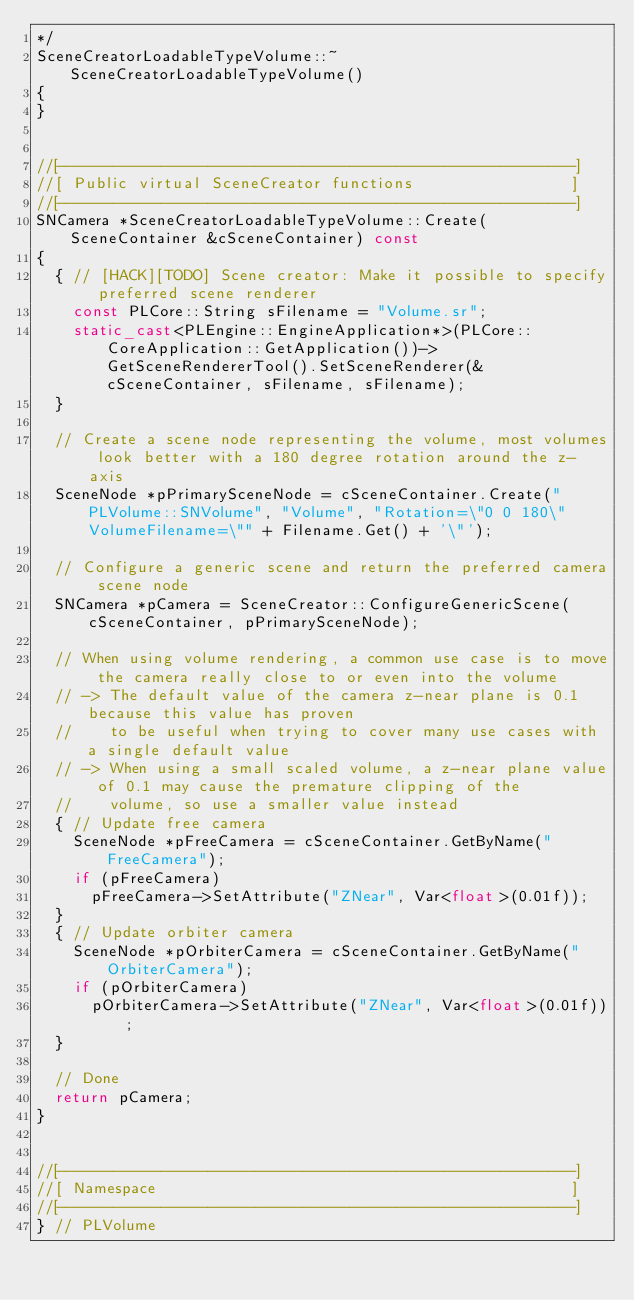<code> <loc_0><loc_0><loc_500><loc_500><_C++_>*/
SceneCreatorLoadableTypeVolume::~SceneCreatorLoadableTypeVolume()
{
}


//[-------------------------------------------------------]
//[ Public virtual SceneCreator functions                 ]
//[-------------------------------------------------------]
SNCamera *SceneCreatorLoadableTypeVolume::Create(SceneContainer &cSceneContainer) const
{
	{ // [HACK][TODO] Scene creator: Make it possible to specify preferred scene renderer
		const PLCore::String sFilename = "Volume.sr";
		static_cast<PLEngine::EngineApplication*>(PLCore::CoreApplication::GetApplication())->GetSceneRendererTool().SetSceneRenderer(&cSceneContainer, sFilename, sFilename);
	}

	// Create a scene node representing the volume, most volumes look better with a 180 degree rotation around the z-axis
	SceneNode *pPrimarySceneNode = cSceneContainer.Create("PLVolume::SNVolume", "Volume", "Rotation=\"0 0 180\" VolumeFilename=\"" + Filename.Get() + '\"');

	// Configure a generic scene and return the preferred camera scene node
	SNCamera *pCamera = SceneCreator::ConfigureGenericScene(cSceneContainer, pPrimarySceneNode);

	// When using volume rendering, a common use case is to move the camera really close to or even into the volume
	// -> The default value of the camera z-near plane is 0.1 because this value has proven
	//    to be useful when trying to cover many use cases with a single default value
	// -> When using a small scaled volume, a z-near plane value of 0.1 may cause the premature clipping of the
	//    volume, so use a smaller value instead
	{ // Update free camera
		SceneNode *pFreeCamera = cSceneContainer.GetByName("FreeCamera");
		if (pFreeCamera)
			pFreeCamera->SetAttribute("ZNear", Var<float>(0.01f));
	}
	{ // Update orbiter camera
		SceneNode *pOrbiterCamera = cSceneContainer.GetByName("OrbiterCamera");
		if (pOrbiterCamera)
			pOrbiterCamera->SetAttribute("ZNear", Var<float>(0.01f));
	}

	// Done
	return pCamera;
}


//[-------------------------------------------------------]
//[ Namespace                                             ]
//[-------------------------------------------------------]
} // PLVolume
</code> 